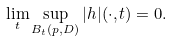Convert formula to latex. <formula><loc_0><loc_0><loc_500><loc_500>\lim _ { t } \sup _ { B _ { t } ( p , D ) } | h | ( \cdot , t ) = 0 .</formula> 